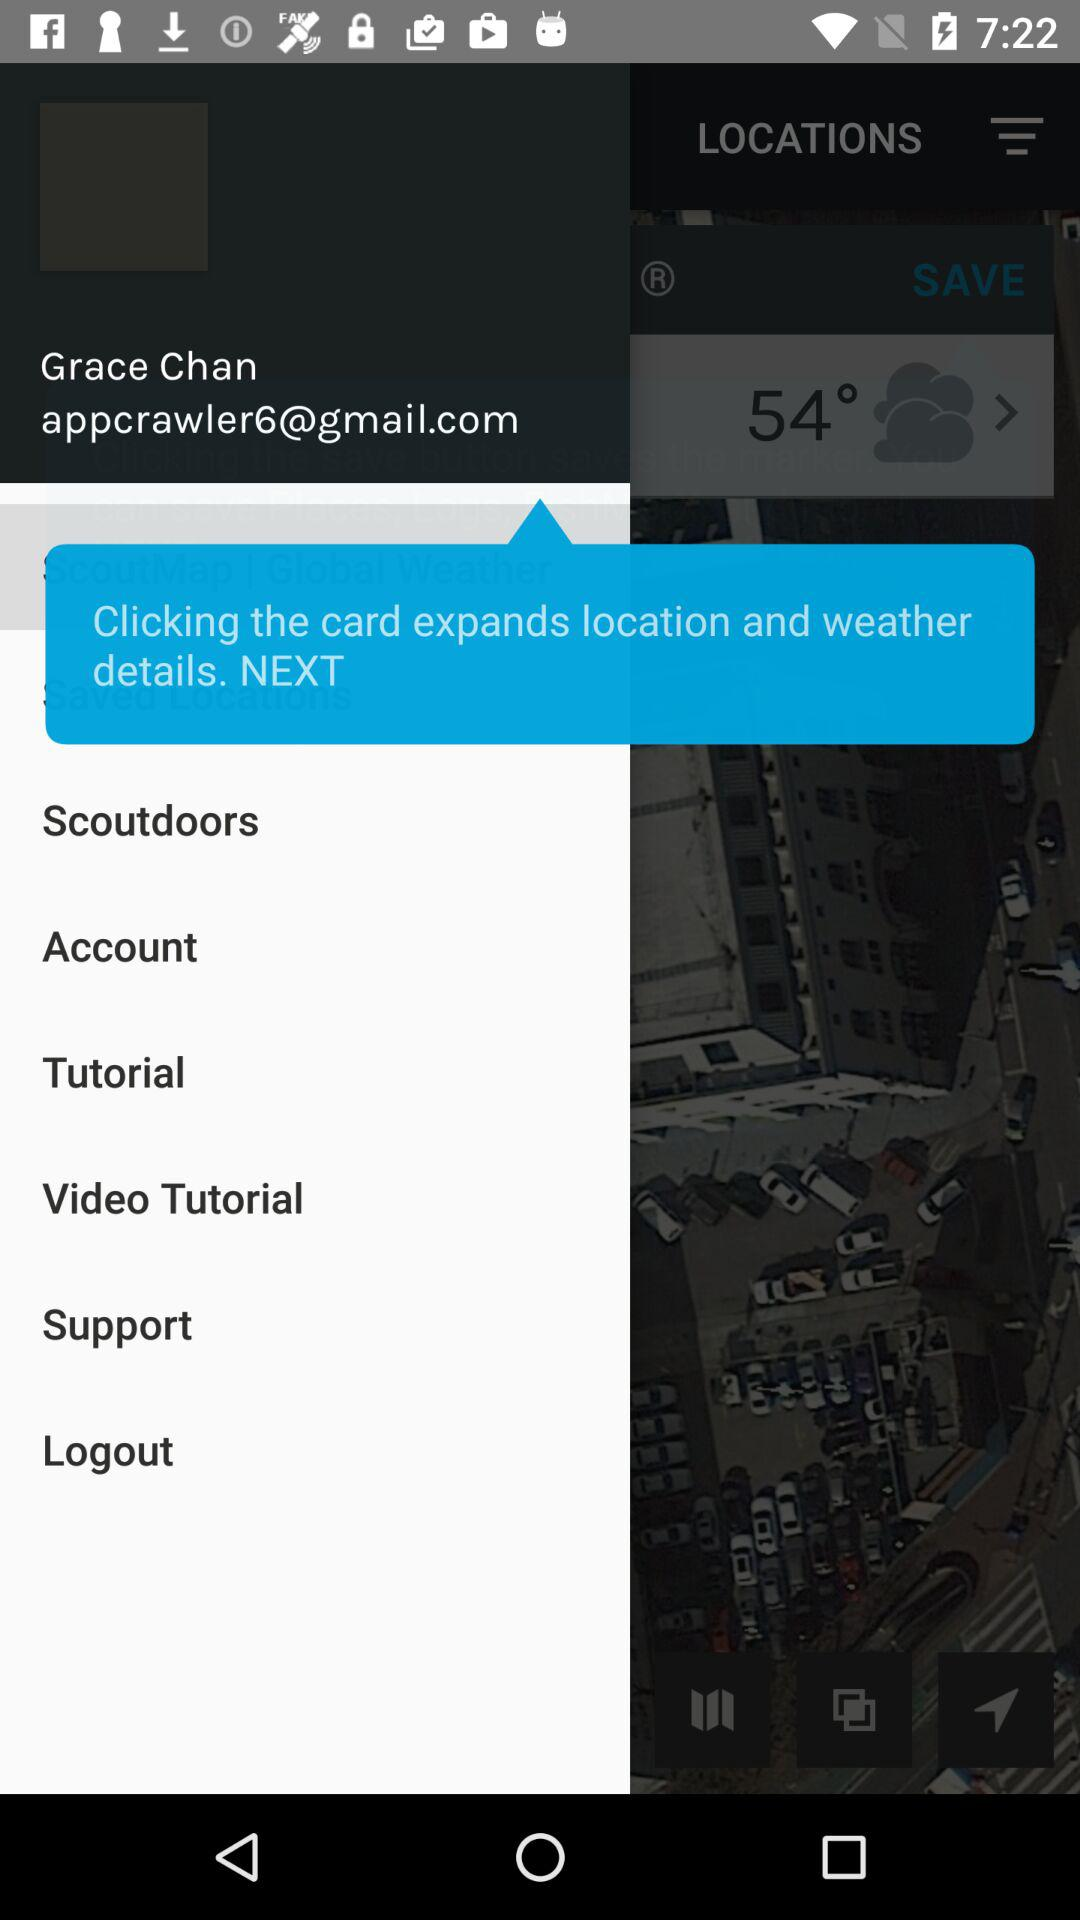What is the user name? The user name is Grace Chan. 